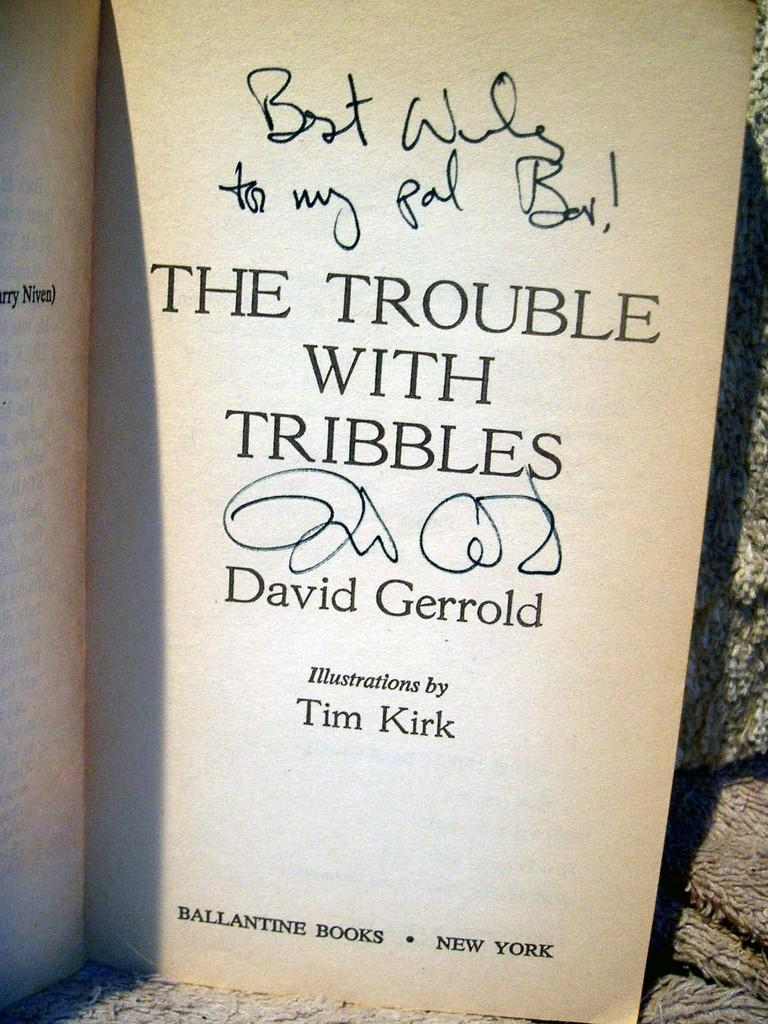<image>
Give a short and clear explanation of the subsequent image. A book open to the title page reading The Trouble with Tribbles. 